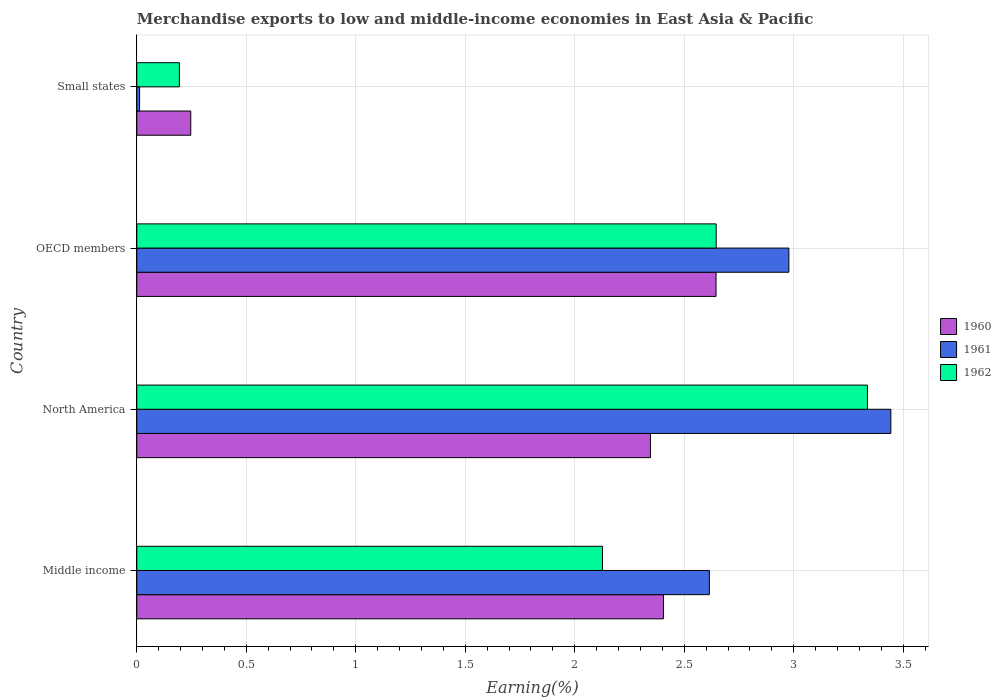How many different coloured bars are there?
Give a very brief answer. 3. How many bars are there on the 2nd tick from the bottom?
Give a very brief answer. 3. What is the label of the 1st group of bars from the top?
Offer a terse response. Small states. In how many cases, is the number of bars for a given country not equal to the number of legend labels?
Provide a succinct answer. 0. What is the percentage of amount earned from merchandise exports in 1961 in Middle income?
Ensure brevity in your answer.  2.61. Across all countries, what is the maximum percentage of amount earned from merchandise exports in 1960?
Offer a terse response. 2.65. Across all countries, what is the minimum percentage of amount earned from merchandise exports in 1961?
Give a very brief answer. 0.01. In which country was the percentage of amount earned from merchandise exports in 1961 minimum?
Keep it short and to the point. Small states. What is the total percentage of amount earned from merchandise exports in 1962 in the graph?
Make the answer very short. 8.3. What is the difference between the percentage of amount earned from merchandise exports in 1962 in Middle income and that in OECD members?
Give a very brief answer. -0.52. What is the difference between the percentage of amount earned from merchandise exports in 1961 in Small states and the percentage of amount earned from merchandise exports in 1960 in OECD members?
Your answer should be compact. -2.63. What is the average percentage of amount earned from merchandise exports in 1962 per country?
Provide a short and direct response. 2.08. What is the difference between the percentage of amount earned from merchandise exports in 1961 and percentage of amount earned from merchandise exports in 1960 in North America?
Make the answer very short. 1.1. What is the ratio of the percentage of amount earned from merchandise exports in 1962 in Middle income to that in North America?
Provide a short and direct response. 0.64. Is the percentage of amount earned from merchandise exports in 1962 in OECD members less than that in Small states?
Provide a succinct answer. No. Is the difference between the percentage of amount earned from merchandise exports in 1961 in OECD members and Small states greater than the difference between the percentage of amount earned from merchandise exports in 1960 in OECD members and Small states?
Your answer should be very brief. Yes. What is the difference between the highest and the second highest percentage of amount earned from merchandise exports in 1962?
Your answer should be compact. 0.69. What is the difference between the highest and the lowest percentage of amount earned from merchandise exports in 1960?
Give a very brief answer. 2.4. Is the sum of the percentage of amount earned from merchandise exports in 1962 in North America and OECD members greater than the maximum percentage of amount earned from merchandise exports in 1960 across all countries?
Your answer should be compact. Yes. What does the 1st bar from the bottom in North America represents?
Your answer should be compact. 1960. Is it the case that in every country, the sum of the percentage of amount earned from merchandise exports in 1962 and percentage of amount earned from merchandise exports in 1961 is greater than the percentage of amount earned from merchandise exports in 1960?
Give a very brief answer. No. What is the difference between two consecutive major ticks on the X-axis?
Offer a terse response. 0.5. Where does the legend appear in the graph?
Keep it short and to the point. Center right. How many legend labels are there?
Give a very brief answer. 3. What is the title of the graph?
Provide a succinct answer. Merchandise exports to low and middle-income economies in East Asia & Pacific. What is the label or title of the X-axis?
Ensure brevity in your answer.  Earning(%). What is the Earning(%) of 1960 in Middle income?
Provide a succinct answer. 2.4. What is the Earning(%) in 1961 in Middle income?
Offer a very short reply. 2.61. What is the Earning(%) of 1962 in Middle income?
Ensure brevity in your answer.  2.13. What is the Earning(%) of 1960 in North America?
Provide a short and direct response. 2.35. What is the Earning(%) in 1961 in North America?
Offer a very short reply. 3.44. What is the Earning(%) in 1962 in North America?
Provide a short and direct response. 3.34. What is the Earning(%) of 1960 in OECD members?
Your answer should be compact. 2.65. What is the Earning(%) in 1961 in OECD members?
Your answer should be very brief. 2.98. What is the Earning(%) in 1962 in OECD members?
Offer a very short reply. 2.65. What is the Earning(%) of 1960 in Small states?
Offer a very short reply. 0.25. What is the Earning(%) of 1961 in Small states?
Provide a succinct answer. 0.01. What is the Earning(%) of 1962 in Small states?
Provide a succinct answer. 0.19. Across all countries, what is the maximum Earning(%) in 1960?
Give a very brief answer. 2.65. Across all countries, what is the maximum Earning(%) in 1961?
Your response must be concise. 3.44. Across all countries, what is the maximum Earning(%) of 1962?
Offer a terse response. 3.34. Across all countries, what is the minimum Earning(%) of 1960?
Your response must be concise. 0.25. Across all countries, what is the minimum Earning(%) in 1961?
Offer a terse response. 0.01. Across all countries, what is the minimum Earning(%) in 1962?
Your answer should be compact. 0.19. What is the total Earning(%) of 1960 in the graph?
Offer a very short reply. 7.64. What is the total Earning(%) in 1961 in the graph?
Offer a very short reply. 9.05. What is the total Earning(%) in 1962 in the graph?
Your answer should be compact. 8.3. What is the difference between the Earning(%) of 1960 in Middle income and that in North America?
Provide a succinct answer. 0.06. What is the difference between the Earning(%) in 1961 in Middle income and that in North America?
Your answer should be very brief. -0.83. What is the difference between the Earning(%) in 1962 in Middle income and that in North America?
Keep it short and to the point. -1.21. What is the difference between the Earning(%) in 1960 in Middle income and that in OECD members?
Offer a very short reply. -0.24. What is the difference between the Earning(%) of 1961 in Middle income and that in OECD members?
Give a very brief answer. -0.36. What is the difference between the Earning(%) of 1962 in Middle income and that in OECD members?
Make the answer very short. -0.52. What is the difference between the Earning(%) in 1960 in Middle income and that in Small states?
Provide a succinct answer. 2.16. What is the difference between the Earning(%) of 1961 in Middle income and that in Small states?
Provide a short and direct response. 2.6. What is the difference between the Earning(%) of 1962 in Middle income and that in Small states?
Your response must be concise. 1.93. What is the difference between the Earning(%) of 1960 in North America and that in OECD members?
Ensure brevity in your answer.  -0.3. What is the difference between the Earning(%) in 1961 in North America and that in OECD members?
Give a very brief answer. 0.47. What is the difference between the Earning(%) of 1962 in North America and that in OECD members?
Keep it short and to the point. 0.69. What is the difference between the Earning(%) in 1960 in North America and that in Small states?
Your response must be concise. 2.1. What is the difference between the Earning(%) of 1961 in North America and that in Small states?
Provide a short and direct response. 3.43. What is the difference between the Earning(%) of 1962 in North America and that in Small states?
Provide a short and direct response. 3.14. What is the difference between the Earning(%) of 1960 in OECD members and that in Small states?
Your answer should be very brief. 2.4. What is the difference between the Earning(%) of 1961 in OECD members and that in Small states?
Ensure brevity in your answer.  2.96. What is the difference between the Earning(%) in 1962 in OECD members and that in Small states?
Provide a short and direct response. 2.45. What is the difference between the Earning(%) of 1960 in Middle income and the Earning(%) of 1961 in North America?
Keep it short and to the point. -1.04. What is the difference between the Earning(%) of 1960 in Middle income and the Earning(%) of 1962 in North America?
Your response must be concise. -0.93. What is the difference between the Earning(%) in 1961 in Middle income and the Earning(%) in 1962 in North America?
Offer a terse response. -0.72. What is the difference between the Earning(%) in 1960 in Middle income and the Earning(%) in 1961 in OECD members?
Offer a terse response. -0.57. What is the difference between the Earning(%) in 1960 in Middle income and the Earning(%) in 1962 in OECD members?
Your answer should be very brief. -0.24. What is the difference between the Earning(%) of 1961 in Middle income and the Earning(%) of 1962 in OECD members?
Offer a very short reply. -0.03. What is the difference between the Earning(%) in 1960 in Middle income and the Earning(%) in 1961 in Small states?
Provide a succinct answer. 2.39. What is the difference between the Earning(%) of 1960 in Middle income and the Earning(%) of 1962 in Small states?
Make the answer very short. 2.21. What is the difference between the Earning(%) of 1961 in Middle income and the Earning(%) of 1962 in Small states?
Your answer should be compact. 2.42. What is the difference between the Earning(%) in 1960 in North America and the Earning(%) in 1961 in OECD members?
Ensure brevity in your answer.  -0.63. What is the difference between the Earning(%) in 1960 in North America and the Earning(%) in 1962 in OECD members?
Your response must be concise. -0.3. What is the difference between the Earning(%) in 1961 in North America and the Earning(%) in 1962 in OECD members?
Your response must be concise. 0.8. What is the difference between the Earning(%) in 1960 in North America and the Earning(%) in 1961 in Small states?
Your answer should be very brief. 2.33. What is the difference between the Earning(%) in 1960 in North America and the Earning(%) in 1962 in Small states?
Keep it short and to the point. 2.15. What is the difference between the Earning(%) of 1961 in North America and the Earning(%) of 1962 in Small states?
Ensure brevity in your answer.  3.25. What is the difference between the Earning(%) in 1960 in OECD members and the Earning(%) in 1961 in Small states?
Make the answer very short. 2.63. What is the difference between the Earning(%) in 1960 in OECD members and the Earning(%) in 1962 in Small states?
Make the answer very short. 2.45. What is the difference between the Earning(%) in 1961 in OECD members and the Earning(%) in 1962 in Small states?
Make the answer very short. 2.78. What is the average Earning(%) of 1960 per country?
Your response must be concise. 1.91. What is the average Earning(%) in 1961 per country?
Your answer should be very brief. 2.26. What is the average Earning(%) of 1962 per country?
Your answer should be very brief. 2.08. What is the difference between the Earning(%) of 1960 and Earning(%) of 1961 in Middle income?
Make the answer very short. -0.21. What is the difference between the Earning(%) of 1960 and Earning(%) of 1962 in Middle income?
Make the answer very short. 0.28. What is the difference between the Earning(%) in 1961 and Earning(%) in 1962 in Middle income?
Your response must be concise. 0.49. What is the difference between the Earning(%) of 1960 and Earning(%) of 1961 in North America?
Your response must be concise. -1.1. What is the difference between the Earning(%) of 1960 and Earning(%) of 1962 in North America?
Offer a very short reply. -0.99. What is the difference between the Earning(%) in 1961 and Earning(%) in 1962 in North America?
Give a very brief answer. 0.11. What is the difference between the Earning(%) of 1960 and Earning(%) of 1961 in OECD members?
Provide a short and direct response. -0.33. What is the difference between the Earning(%) of 1960 and Earning(%) of 1962 in OECD members?
Give a very brief answer. -0. What is the difference between the Earning(%) in 1961 and Earning(%) in 1962 in OECD members?
Keep it short and to the point. 0.33. What is the difference between the Earning(%) of 1960 and Earning(%) of 1961 in Small states?
Offer a terse response. 0.23. What is the difference between the Earning(%) of 1960 and Earning(%) of 1962 in Small states?
Your answer should be compact. 0.05. What is the difference between the Earning(%) in 1961 and Earning(%) in 1962 in Small states?
Your answer should be compact. -0.18. What is the ratio of the Earning(%) of 1960 in Middle income to that in North America?
Ensure brevity in your answer.  1.03. What is the ratio of the Earning(%) in 1961 in Middle income to that in North America?
Ensure brevity in your answer.  0.76. What is the ratio of the Earning(%) in 1962 in Middle income to that in North America?
Make the answer very short. 0.64. What is the ratio of the Earning(%) of 1960 in Middle income to that in OECD members?
Offer a terse response. 0.91. What is the ratio of the Earning(%) of 1961 in Middle income to that in OECD members?
Ensure brevity in your answer.  0.88. What is the ratio of the Earning(%) in 1962 in Middle income to that in OECD members?
Offer a very short reply. 0.8. What is the ratio of the Earning(%) of 1960 in Middle income to that in Small states?
Give a very brief answer. 9.76. What is the ratio of the Earning(%) of 1961 in Middle income to that in Small states?
Your response must be concise. 205.79. What is the ratio of the Earning(%) of 1962 in Middle income to that in Small states?
Make the answer very short. 10.94. What is the ratio of the Earning(%) in 1960 in North America to that in OECD members?
Your response must be concise. 0.89. What is the ratio of the Earning(%) of 1961 in North America to that in OECD members?
Your answer should be very brief. 1.16. What is the ratio of the Earning(%) of 1962 in North America to that in OECD members?
Your response must be concise. 1.26. What is the ratio of the Earning(%) of 1960 in North America to that in Small states?
Ensure brevity in your answer.  9.52. What is the ratio of the Earning(%) of 1961 in North America to that in Small states?
Provide a short and direct response. 271.02. What is the ratio of the Earning(%) in 1962 in North America to that in Small states?
Offer a terse response. 17.16. What is the ratio of the Earning(%) of 1960 in OECD members to that in Small states?
Make the answer very short. 10.74. What is the ratio of the Earning(%) of 1961 in OECD members to that in Small states?
Offer a very short reply. 234.37. What is the ratio of the Earning(%) in 1962 in OECD members to that in Small states?
Keep it short and to the point. 13.61. What is the difference between the highest and the second highest Earning(%) of 1960?
Make the answer very short. 0.24. What is the difference between the highest and the second highest Earning(%) in 1961?
Provide a succinct answer. 0.47. What is the difference between the highest and the second highest Earning(%) of 1962?
Make the answer very short. 0.69. What is the difference between the highest and the lowest Earning(%) in 1960?
Offer a terse response. 2.4. What is the difference between the highest and the lowest Earning(%) in 1961?
Keep it short and to the point. 3.43. What is the difference between the highest and the lowest Earning(%) of 1962?
Your response must be concise. 3.14. 